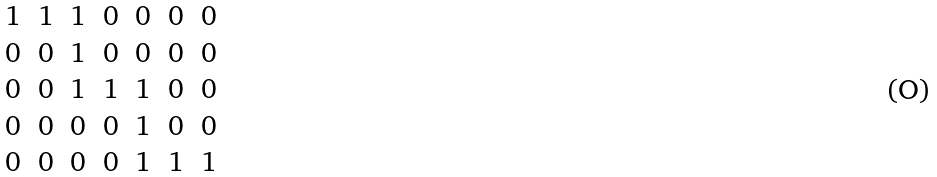Convert formula to latex. <formula><loc_0><loc_0><loc_500><loc_500>\begin{matrix} 1 & 1 & 1 & 0 & 0 & 0 & 0 \\ 0 & 0 & 1 & 0 & 0 & 0 & 0 \\ 0 & 0 & 1 & 1 & 1 & 0 & 0 \\ 0 & 0 & 0 & 0 & 1 & 0 & 0 \\ 0 & 0 & 0 & 0 & 1 & 1 & 1 \end{matrix}</formula> 